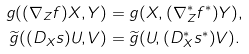Convert formula to latex. <formula><loc_0><loc_0><loc_500><loc_500>g ( ( \nabla _ { Z } f ) X , Y ) & = g ( X , ( \nabla ^ { \ast } _ { Z } f ^ { \ast } ) Y ) , \\ \widetilde { g } ( ( D _ { X } s ) U , V ) & = \widetilde { g } ( U , ( D ^ { \ast } _ { X } s ^ { \ast } ) V ) .</formula> 